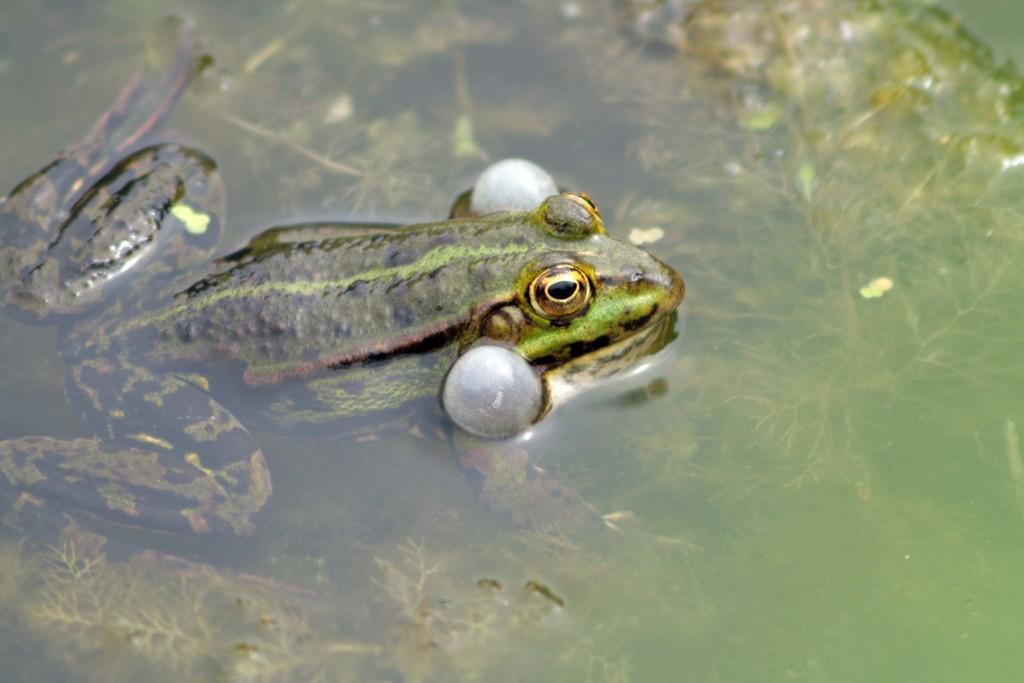In one or two sentences, can you explain what this image depicts? In this image I can see the water, few plants inside the water and a frog which is green, black, white and brown in color in the water. 